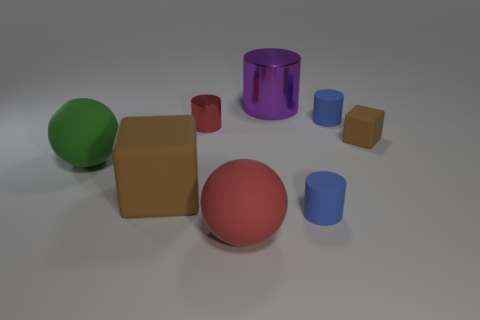Subtract all red cylinders. How many cylinders are left? 3 Subtract all red cylinders. How many cylinders are left? 3 Add 2 small brown things. How many objects exist? 10 Subtract all cyan cylinders. Subtract all red cubes. How many cylinders are left? 4 Subtract all spheres. How many objects are left? 6 Add 3 shiny cylinders. How many shiny cylinders exist? 5 Subtract 0 gray spheres. How many objects are left? 8 Subtract all green metal things. Subtract all red metallic things. How many objects are left? 7 Add 3 large spheres. How many large spheres are left? 5 